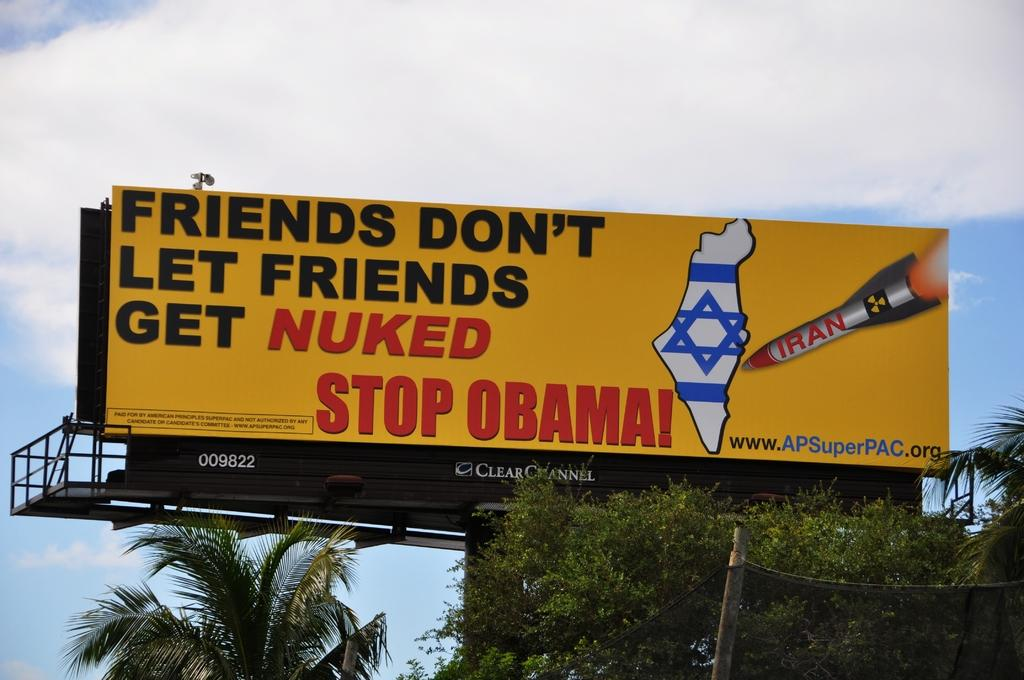<image>
Give a short and clear explanation of the subsequent image. A billboard with a Star of David on it asks that Obama be stopped. 